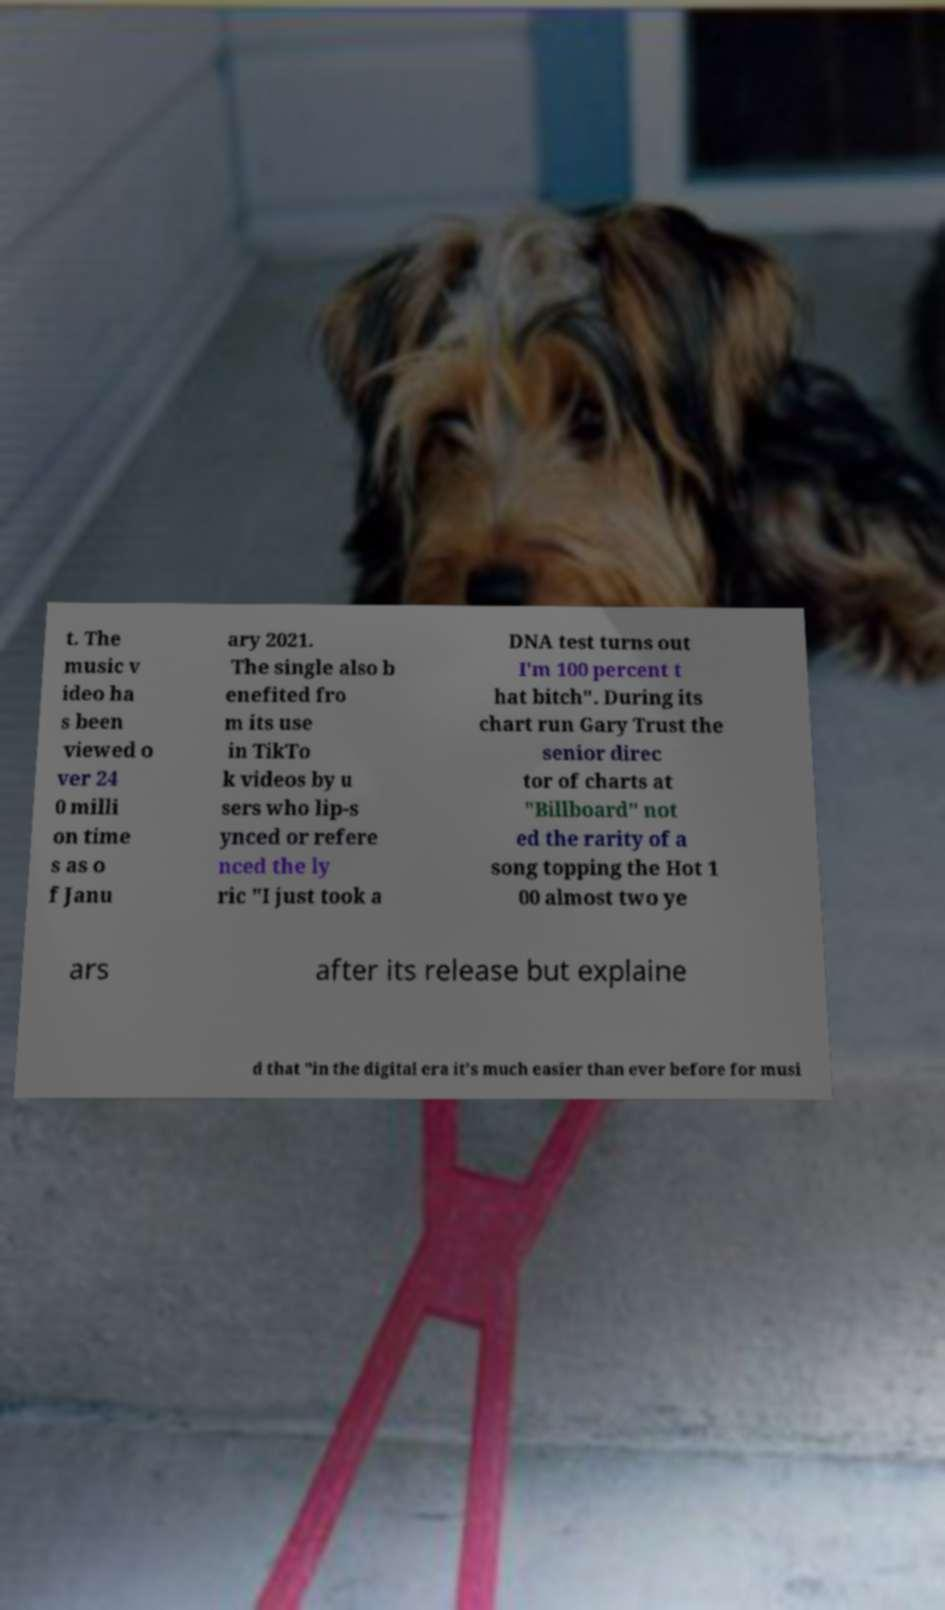I need the written content from this picture converted into text. Can you do that? t. The music v ideo ha s been viewed o ver 24 0 milli on time s as o f Janu ary 2021. The single also b enefited fro m its use in TikTo k videos by u sers who lip-s ynced or refere nced the ly ric "I just took a DNA test turns out I'm 100 percent t hat bitch". During its chart run Gary Trust the senior direc tor of charts at "Billboard" not ed the rarity of a song topping the Hot 1 00 almost two ye ars after its release but explaine d that "in the digital era it's much easier than ever before for musi 